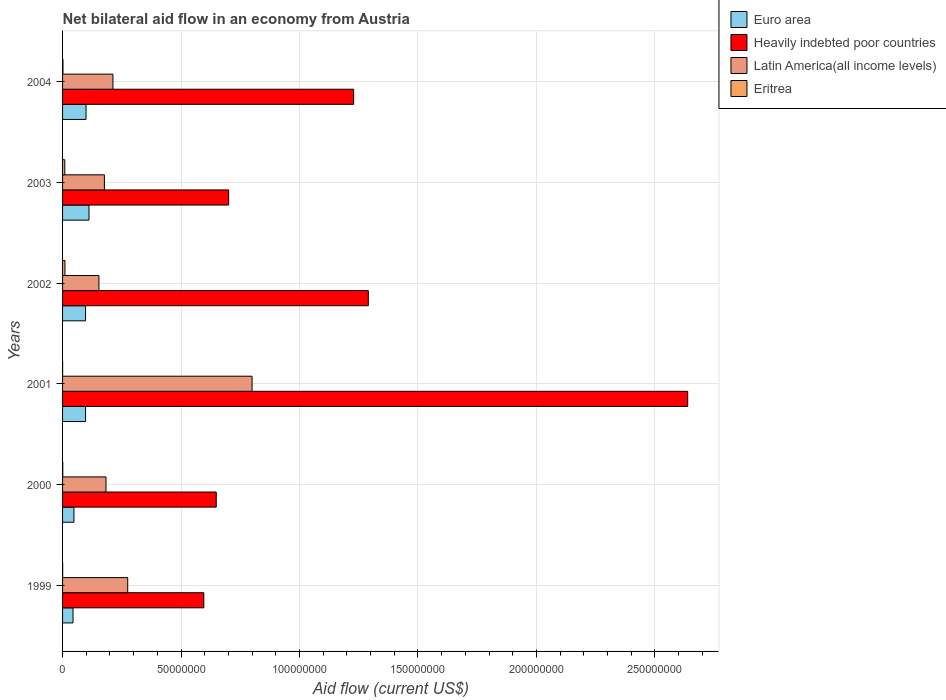How many groups of bars are there?
Ensure brevity in your answer.  6. What is the label of the 4th group of bars from the top?
Give a very brief answer. 2001. What is the net bilateral aid flow in Latin America(all income levels) in 2003?
Give a very brief answer. 1.77e+07. Across all years, what is the maximum net bilateral aid flow in Heavily indebted poor countries?
Make the answer very short. 2.64e+08. Across all years, what is the minimum net bilateral aid flow in Euro area?
Offer a very short reply. 4.42e+06. In which year was the net bilateral aid flow in Latin America(all income levels) maximum?
Your answer should be compact. 2001. What is the total net bilateral aid flow in Eritrea in the graph?
Make the answer very short. 2.27e+06. What is the difference between the net bilateral aid flow in Heavily indebted poor countries in 2003 and that in 2004?
Keep it short and to the point. -5.27e+07. What is the difference between the net bilateral aid flow in Latin America(all income levels) in 2003 and the net bilateral aid flow in Heavily indebted poor countries in 2002?
Keep it short and to the point. -1.11e+08. What is the average net bilateral aid flow in Latin America(all income levels) per year?
Provide a succinct answer. 3.00e+07. In the year 2002, what is the difference between the net bilateral aid flow in Latin America(all income levels) and net bilateral aid flow in Eritrea?
Keep it short and to the point. 1.43e+07. What is the ratio of the net bilateral aid flow in Heavily indebted poor countries in 2003 to that in 2004?
Make the answer very short. 0.57. Is the net bilateral aid flow in Eritrea in 2002 less than that in 2003?
Keep it short and to the point. No. What is the difference between the highest and the second highest net bilateral aid flow in Euro area?
Your answer should be very brief. 1.25e+06. What is the difference between the highest and the lowest net bilateral aid flow in Euro area?
Ensure brevity in your answer.  6.74e+06. In how many years, is the net bilateral aid flow in Euro area greater than the average net bilateral aid flow in Euro area taken over all years?
Offer a terse response. 4. Is the sum of the net bilateral aid flow in Euro area in 1999 and 2002 greater than the maximum net bilateral aid flow in Heavily indebted poor countries across all years?
Provide a short and direct response. No. What does the 3rd bar from the top in 2004 represents?
Provide a short and direct response. Heavily indebted poor countries. What does the 2nd bar from the bottom in 2000 represents?
Ensure brevity in your answer.  Heavily indebted poor countries. Are all the bars in the graph horizontal?
Offer a very short reply. Yes. Where does the legend appear in the graph?
Ensure brevity in your answer.  Top right. How are the legend labels stacked?
Offer a terse response. Vertical. What is the title of the graph?
Offer a very short reply. Net bilateral aid flow in an economy from Austria. Does "Thailand" appear as one of the legend labels in the graph?
Provide a short and direct response. No. What is the Aid flow (current US$) of Euro area in 1999?
Your answer should be compact. 4.42e+06. What is the Aid flow (current US$) of Heavily indebted poor countries in 1999?
Provide a short and direct response. 5.96e+07. What is the Aid flow (current US$) of Latin America(all income levels) in 1999?
Keep it short and to the point. 2.75e+07. What is the Aid flow (current US$) of Euro area in 2000?
Give a very brief answer. 4.80e+06. What is the Aid flow (current US$) in Heavily indebted poor countries in 2000?
Your answer should be very brief. 6.49e+07. What is the Aid flow (current US$) of Latin America(all income levels) in 2000?
Provide a short and direct response. 1.83e+07. What is the Aid flow (current US$) of Euro area in 2001?
Your answer should be very brief. 9.71e+06. What is the Aid flow (current US$) of Heavily indebted poor countries in 2001?
Make the answer very short. 2.64e+08. What is the Aid flow (current US$) in Latin America(all income levels) in 2001?
Offer a terse response. 8.00e+07. What is the Aid flow (current US$) of Euro area in 2002?
Keep it short and to the point. 9.71e+06. What is the Aid flow (current US$) in Heavily indebted poor countries in 2002?
Ensure brevity in your answer.  1.29e+08. What is the Aid flow (current US$) of Latin America(all income levels) in 2002?
Your answer should be compact. 1.54e+07. What is the Aid flow (current US$) of Eritrea in 2002?
Provide a short and direct response. 1.01e+06. What is the Aid flow (current US$) in Euro area in 2003?
Offer a very short reply. 1.12e+07. What is the Aid flow (current US$) of Heavily indebted poor countries in 2003?
Your answer should be very brief. 7.01e+07. What is the Aid flow (current US$) of Latin America(all income levels) in 2003?
Provide a succinct answer. 1.77e+07. What is the Aid flow (current US$) of Eritrea in 2003?
Your response must be concise. 9.40e+05. What is the Aid flow (current US$) of Euro area in 2004?
Your answer should be compact. 9.91e+06. What is the Aid flow (current US$) in Heavily indebted poor countries in 2004?
Offer a very short reply. 1.23e+08. What is the Aid flow (current US$) in Latin America(all income levels) in 2004?
Your response must be concise. 2.13e+07. Across all years, what is the maximum Aid flow (current US$) of Euro area?
Your answer should be very brief. 1.12e+07. Across all years, what is the maximum Aid flow (current US$) in Heavily indebted poor countries?
Provide a short and direct response. 2.64e+08. Across all years, what is the maximum Aid flow (current US$) of Latin America(all income levels)?
Keep it short and to the point. 8.00e+07. Across all years, what is the maximum Aid flow (current US$) in Eritrea?
Give a very brief answer. 1.01e+06. Across all years, what is the minimum Aid flow (current US$) in Euro area?
Your answer should be very brief. 4.42e+06. Across all years, what is the minimum Aid flow (current US$) of Heavily indebted poor countries?
Give a very brief answer. 5.96e+07. Across all years, what is the minimum Aid flow (current US$) in Latin America(all income levels)?
Ensure brevity in your answer.  1.54e+07. What is the total Aid flow (current US$) of Euro area in the graph?
Ensure brevity in your answer.  4.97e+07. What is the total Aid flow (current US$) in Heavily indebted poor countries in the graph?
Your answer should be compact. 7.10e+08. What is the total Aid flow (current US$) in Latin America(all income levels) in the graph?
Your answer should be very brief. 1.80e+08. What is the total Aid flow (current US$) in Eritrea in the graph?
Your answer should be very brief. 2.27e+06. What is the difference between the Aid flow (current US$) in Euro area in 1999 and that in 2000?
Offer a terse response. -3.80e+05. What is the difference between the Aid flow (current US$) in Heavily indebted poor countries in 1999 and that in 2000?
Make the answer very short. -5.24e+06. What is the difference between the Aid flow (current US$) of Latin America(all income levels) in 1999 and that in 2000?
Your response must be concise. 9.17e+06. What is the difference between the Aid flow (current US$) in Eritrea in 1999 and that in 2000?
Provide a succinct answer. -5.00e+04. What is the difference between the Aid flow (current US$) in Euro area in 1999 and that in 2001?
Keep it short and to the point. -5.29e+06. What is the difference between the Aid flow (current US$) of Heavily indebted poor countries in 1999 and that in 2001?
Ensure brevity in your answer.  -2.04e+08. What is the difference between the Aid flow (current US$) of Latin America(all income levels) in 1999 and that in 2001?
Provide a succinct answer. -5.25e+07. What is the difference between the Aid flow (current US$) of Eritrea in 1999 and that in 2001?
Give a very brief answer. 2.00e+04. What is the difference between the Aid flow (current US$) of Euro area in 1999 and that in 2002?
Give a very brief answer. -5.29e+06. What is the difference between the Aid flow (current US$) of Heavily indebted poor countries in 1999 and that in 2002?
Keep it short and to the point. -6.94e+07. What is the difference between the Aid flow (current US$) in Latin America(all income levels) in 1999 and that in 2002?
Make the answer very short. 1.22e+07. What is the difference between the Aid flow (current US$) in Eritrea in 1999 and that in 2002?
Give a very brief answer. -9.70e+05. What is the difference between the Aid flow (current US$) in Euro area in 1999 and that in 2003?
Provide a short and direct response. -6.74e+06. What is the difference between the Aid flow (current US$) of Heavily indebted poor countries in 1999 and that in 2003?
Ensure brevity in your answer.  -1.05e+07. What is the difference between the Aid flow (current US$) in Latin America(all income levels) in 1999 and that in 2003?
Give a very brief answer. 9.84e+06. What is the difference between the Aid flow (current US$) in Eritrea in 1999 and that in 2003?
Your answer should be compact. -9.00e+05. What is the difference between the Aid flow (current US$) of Euro area in 1999 and that in 2004?
Offer a very short reply. -5.49e+06. What is the difference between the Aid flow (current US$) of Heavily indebted poor countries in 1999 and that in 2004?
Make the answer very short. -6.32e+07. What is the difference between the Aid flow (current US$) in Latin America(all income levels) in 1999 and that in 2004?
Make the answer very short. 6.23e+06. What is the difference between the Aid flow (current US$) of Euro area in 2000 and that in 2001?
Your answer should be very brief. -4.91e+06. What is the difference between the Aid flow (current US$) in Heavily indebted poor countries in 2000 and that in 2001?
Your response must be concise. -1.99e+08. What is the difference between the Aid flow (current US$) in Latin America(all income levels) in 2000 and that in 2001?
Your answer should be compact. -6.17e+07. What is the difference between the Aid flow (current US$) in Euro area in 2000 and that in 2002?
Your response must be concise. -4.91e+06. What is the difference between the Aid flow (current US$) in Heavily indebted poor countries in 2000 and that in 2002?
Your answer should be compact. -6.42e+07. What is the difference between the Aid flow (current US$) of Latin America(all income levels) in 2000 and that in 2002?
Provide a succinct answer. 2.98e+06. What is the difference between the Aid flow (current US$) of Eritrea in 2000 and that in 2002?
Provide a short and direct response. -9.20e+05. What is the difference between the Aid flow (current US$) of Euro area in 2000 and that in 2003?
Your response must be concise. -6.36e+06. What is the difference between the Aid flow (current US$) in Heavily indebted poor countries in 2000 and that in 2003?
Provide a short and direct response. -5.24e+06. What is the difference between the Aid flow (current US$) in Latin America(all income levels) in 2000 and that in 2003?
Keep it short and to the point. 6.70e+05. What is the difference between the Aid flow (current US$) of Eritrea in 2000 and that in 2003?
Offer a very short reply. -8.50e+05. What is the difference between the Aid flow (current US$) of Euro area in 2000 and that in 2004?
Provide a succinct answer. -5.11e+06. What is the difference between the Aid flow (current US$) of Heavily indebted poor countries in 2000 and that in 2004?
Your answer should be compact. -5.80e+07. What is the difference between the Aid flow (current US$) of Latin America(all income levels) in 2000 and that in 2004?
Keep it short and to the point. -2.94e+06. What is the difference between the Aid flow (current US$) of Eritrea in 2000 and that in 2004?
Offer a terse response. -8.00e+04. What is the difference between the Aid flow (current US$) of Euro area in 2001 and that in 2002?
Ensure brevity in your answer.  0. What is the difference between the Aid flow (current US$) in Heavily indebted poor countries in 2001 and that in 2002?
Your answer should be very brief. 1.35e+08. What is the difference between the Aid flow (current US$) of Latin America(all income levels) in 2001 and that in 2002?
Provide a short and direct response. 6.46e+07. What is the difference between the Aid flow (current US$) in Eritrea in 2001 and that in 2002?
Provide a short and direct response. -9.90e+05. What is the difference between the Aid flow (current US$) in Euro area in 2001 and that in 2003?
Ensure brevity in your answer.  -1.45e+06. What is the difference between the Aid flow (current US$) in Heavily indebted poor countries in 2001 and that in 2003?
Your answer should be compact. 1.94e+08. What is the difference between the Aid flow (current US$) in Latin America(all income levels) in 2001 and that in 2003?
Ensure brevity in your answer.  6.23e+07. What is the difference between the Aid flow (current US$) of Eritrea in 2001 and that in 2003?
Provide a succinct answer. -9.20e+05. What is the difference between the Aid flow (current US$) of Heavily indebted poor countries in 2001 and that in 2004?
Provide a short and direct response. 1.41e+08. What is the difference between the Aid flow (current US$) of Latin America(all income levels) in 2001 and that in 2004?
Your answer should be very brief. 5.87e+07. What is the difference between the Aid flow (current US$) in Eritrea in 2001 and that in 2004?
Your answer should be very brief. -1.50e+05. What is the difference between the Aid flow (current US$) of Euro area in 2002 and that in 2003?
Make the answer very short. -1.45e+06. What is the difference between the Aid flow (current US$) of Heavily indebted poor countries in 2002 and that in 2003?
Your response must be concise. 5.90e+07. What is the difference between the Aid flow (current US$) in Latin America(all income levels) in 2002 and that in 2003?
Make the answer very short. -2.31e+06. What is the difference between the Aid flow (current US$) of Eritrea in 2002 and that in 2003?
Provide a succinct answer. 7.00e+04. What is the difference between the Aid flow (current US$) of Heavily indebted poor countries in 2002 and that in 2004?
Your answer should be compact. 6.21e+06. What is the difference between the Aid flow (current US$) of Latin America(all income levels) in 2002 and that in 2004?
Ensure brevity in your answer.  -5.92e+06. What is the difference between the Aid flow (current US$) of Eritrea in 2002 and that in 2004?
Give a very brief answer. 8.40e+05. What is the difference between the Aid flow (current US$) in Euro area in 2003 and that in 2004?
Provide a succinct answer. 1.25e+06. What is the difference between the Aid flow (current US$) of Heavily indebted poor countries in 2003 and that in 2004?
Ensure brevity in your answer.  -5.27e+07. What is the difference between the Aid flow (current US$) of Latin America(all income levels) in 2003 and that in 2004?
Your answer should be very brief. -3.61e+06. What is the difference between the Aid flow (current US$) of Eritrea in 2003 and that in 2004?
Provide a short and direct response. 7.70e+05. What is the difference between the Aid flow (current US$) in Euro area in 1999 and the Aid flow (current US$) in Heavily indebted poor countries in 2000?
Your response must be concise. -6.04e+07. What is the difference between the Aid flow (current US$) in Euro area in 1999 and the Aid flow (current US$) in Latin America(all income levels) in 2000?
Provide a short and direct response. -1.39e+07. What is the difference between the Aid flow (current US$) of Euro area in 1999 and the Aid flow (current US$) of Eritrea in 2000?
Offer a terse response. 4.33e+06. What is the difference between the Aid flow (current US$) of Heavily indebted poor countries in 1999 and the Aid flow (current US$) of Latin America(all income levels) in 2000?
Ensure brevity in your answer.  4.13e+07. What is the difference between the Aid flow (current US$) of Heavily indebted poor countries in 1999 and the Aid flow (current US$) of Eritrea in 2000?
Provide a succinct answer. 5.95e+07. What is the difference between the Aid flow (current US$) of Latin America(all income levels) in 1999 and the Aid flow (current US$) of Eritrea in 2000?
Your response must be concise. 2.74e+07. What is the difference between the Aid flow (current US$) of Euro area in 1999 and the Aid flow (current US$) of Heavily indebted poor countries in 2001?
Provide a short and direct response. -2.59e+08. What is the difference between the Aid flow (current US$) of Euro area in 1999 and the Aid flow (current US$) of Latin America(all income levels) in 2001?
Offer a terse response. -7.56e+07. What is the difference between the Aid flow (current US$) in Euro area in 1999 and the Aid flow (current US$) in Eritrea in 2001?
Provide a short and direct response. 4.40e+06. What is the difference between the Aid flow (current US$) in Heavily indebted poor countries in 1999 and the Aid flow (current US$) in Latin America(all income levels) in 2001?
Make the answer very short. -2.04e+07. What is the difference between the Aid flow (current US$) of Heavily indebted poor countries in 1999 and the Aid flow (current US$) of Eritrea in 2001?
Your response must be concise. 5.96e+07. What is the difference between the Aid flow (current US$) of Latin America(all income levels) in 1999 and the Aid flow (current US$) of Eritrea in 2001?
Your answer should be very brief. 2.75e+07. What is the difference between the Aid flow (current US$) of Euro area in 1999 and the Aid flow (current US$) of Heavily indebted poor countries in 2002?
Your answer should be compact. -1.25e+08. What is the difference between the Aid flow (current US$) in Euro area in 1999 and the Aid flow (current US$) in Latin America(all income levels) in 2002?
Your answer should be very brief. -1.09e+07. What is the difference between the Aid flow (current US$) of Euro area in 1999 and the Aid flow (current US$) of Eritrea in 2002?
Ensure brevity in your answer.  3.41e+06. What is the difference between the Aid flow (current US$) of Heavily indebted poor countries in 1999 and the Aid flow (current US$) of Latin America(all income levels) in 2002?
Provide a short and direct response. 4.43e+07. What is the difference between the Aid flow (current US$) of Heavily indebted poor countries in 1999 and the Aid flow (current US$) of Eritrea in 2002?
Offer a terse response. 5.86e+07. What is the difference between the Aid flow (current US$) of Latin America(all income levels) in 1999 and the Aid flow (current US$) of Eritrea in 2002?
Keep it short and to the point. 2.65e+07. What is the difference between the Aid flow (current US$) in Euro area in 1999 and the Aid flow (current US$) in Heavily indebted poor countries in 2003?
Provide a short and direct response. -6.57e+07. What is the difference between the Aid flow (current US$) of Euro area in 1999 and the Aid flow (current US$) of Latin America(all income levels) in 2003?
Your response must be concise. -1.32e+07. What is the difference between the Aid flow (current US$) of Euro area in 1999 and the Aid flow (current US$) of Eritrea in 2003?
Offer a terse response. 3.48e+06. What is the difference between the Aid flow (current US$) of Heavily indebted poor countries in 1999 and the Aid flow (current US$) of Latin America(all income levels) in 2003?
Your answer should be compact. 4.20e+07. What is the difference between the Aid flow (current US$) in Heavily indebted poor countries in 1999 and the Aid flow (current US$) in Eritrea in 2003?
Make the answer very short. 5.87e+07. What is the difference between the Aid flow (current US$) in Latin America(all income levels) in 1999 and the Aid flow (current US$) in Eritrea in 2003?
Make the answer very short. 2.66e+07. What is the difference between the Aid flow (current US$) of Euro area in 1999 and the Aid flow (current US$) of Heavily indebted poor countries in 2004?
Keep it short and to the point. -1.18e+08. What is the difference between the Aid flow (current US$) of Euro area in 1999 and the Aid flow (current US$) of Latin America(all income levels) in 2004?
Your answer should be compact. -1.68e+07. What is the difference between the Aid flow (current US$) of Euro area in 1999 and the Aid flow (current US$) of Eritrea in 2004?
Your answer should be compact. 4.25e+06. What is the difference between the Aid flow (current US$) of Heavily indebted poor countries in 1999 and the Aid flow (current US$) of Latin America(all income levels) in 2004?
Provide a short and direct response. 3.84e+07. What is the difference between the Aid flow (current US$) in Heavily indebted poor countries in 1999 and the Aid flow (current US$) in Eritrea in 2004?
Offer a very short reply. 5.95e+07. What is the difference between the Aid flow (current US$) of Latin America(all income levels) in 1999 and the Aid flow (current US$) of Eritrea in 2004?
Keep it short and to the point. 2.73e+07. What is the difference between the Aid flow (current US$) in Euro area in 2000 and the Aid flow (current US$) in Heavily indebted poor countries in 2001?
Your response must be concise. -2.59e+08. What is the difference between the Aid flow (current US$) of Euro area in 2000 and the Aid flow (current US$) of Latin America(all income levels) in 2001?
Give a very brief answer. -7.52e+07. What is the difference between the Aid flow (current US$) in Euro area in 2000 and the Aid flow (current US$) in Eritrea in 2001?
Ensure brevity in your answer.  4.78e+06. What is the difference between the Aid flow (current US$) in Heavily indebted poor countries in 2000 and the Aid flow (current US$) in Latin America(all income levels) in 2001?
Give a very brief answer. -1.51e+07. What is the difference between the Aid flow (current US$) of Heavily indebted poor countries in 2000 and the Aid flow (current US$) of Eritrea in 2001?
Offer a very short reply. 6.48e+07. What is the difference between the Aid flow (current US$) of Latin America(all income levels) in 2000 and the Aid flow (current US$) of Eritrea in 2001?
Your response must be concise. 1.83e+07. What is the difference between the Aid flow (current US$) of Euro area in 2000 and the Aid flow (current US$) of Heavily indebted poor countries in 2002?
Your answer should be compact. -1.24e+08. What is the difference between the Aid flow (current US$) of Euro area in 2000 and the Aid flow (current US$) of Latin America(all income levels) in 2002?
Your response must be concise. -1.06e+07. What is the difference between the Aid flow (current US$) of Euro area in 2000 and the Aid flow (current US$) of Eritrea in 2002?
Offer a very short reply. 3.79e+06. What is the difference between the Aid flow (current US$) of Heavily indebted poor countries in 2000 and the Aid flow (current US$) of Latin America(all income levels) in 2002?
Provide a short and direct response. 4.95e+07. What is the difference between the Aid flow (current US$) of Heavily indebted poor countries in 2000 and the Aid flow (current US$) of Eritrea in 2002?
Ensure brevity in your answer.  6.39e+07. What is the difference between the Aid flow (current US$) in Latin America(all income levels) in 2000 and the Aid flow (current US$) in Eritrea in 2002?
Your answer should be very brief. 1.73e+07. What is the difference between the Aid flow (current US$) in Euro area in 2000 and the Aid flow (current US$) in Heavily indebted poor countries in 2003?
Offer a terse response. -6.53e+07. What is the difference between the Aid flow (current US$) of Euro area in 2000 and the Aid flow (current US$) of Latin America(all income levels) in 2003?
Make the answer very short. -1.29e+07. What is the difference between the Aid flow (current US$) of Euro area in 2000 and the Aid flow (current US$) of Eritrea in 2003?
Offer a terse response. 3.86e+06. What is the difference between the Aid flow (current US$) of Heavily indebted poor countries in 2000 and the Aid flow (current US$) of Latin America(all income levels) in 2003?
Provide a succinct answer. 4.72e+07. What is the difference between the Aid flow (current US$) of Heavily indebted poor countries in 2000 and the Aid flow (current US$) of Eritrea in 2003?
Keep it short and to the point. 6.39e+07. What is the difference between the Aid flow (current US$) in Latin America(all income levels) in 2000 and the Aid flow (current US$) in Eritrea in 2003?
Provide a succinct answer. 1.74e+07. What is the difference between the Aid flow (current US$) of Euro area in 2000 and the Aid flow (current US$) of Heavily indebted poor countries in 2004?
Your answer should be compact. -1.18e+08. What is the difference between the Aid flow (current US$) of Euro area in 2000 and the Aid flow (current US$) of Latin America(all income levels) in 2004?
Ensure brevity in your answer.  -1.65e+07. What is the difference between the Aid flow (current US$) of Euro area in 2000 and the Aid flow (current US$) of Eritrea in 2004?
Keep it short and to the point. 4.63e+06. What is the difference between the Aid flow (current US$) of Heavily indebted poor countries in 2000 and the Aid flow (current US$) of Latin America(all income levels) in 2004?
Offer a terse response. 4.36e+07. What is the difference between the Aid flow (current US$) in Heavily indebted poor countries in 2000 and the Aid flow (current US$) in Eritrea in 2004?
Keep it short and to the point. 6.47e+07. What is the difference between the Aid flow (current US$) in Latin America(all income levels) in 2000 and the Aid flow (current US$) in Eritrea in 2004?
Your answer should be compact. 1.82e+07. What is the difference between the Aid flow (current US$) in Euro area in 2001 and the Aid flow (current US$) in Heavily indebted poor countries in 2002?
Provide a succinct answer. -1.19e+08. What is the difference between the Aid flow (current US$) in Euro area in 2001 and the Aid flow (current US$) in Latin America(all income levels) in 2002?
Your answer should be compact. -5.64e+06. What is the difference between the Aid flow (current US$) of Euro area in 2001 and the Aid flow (current US$) of Eritrea in 2002?
Ensure brevity in your answer.  8.70e+06. What is the difference between the Aid flow (current US$) of Heavily indebted poor countries in 2001 and the Aid flow (current US$) of Latin America(all income levels) in 2002?
Your answer should be very brief. 2.49e+08. What is the difference between the Aid flow (current US$) of Heavily indebted poor countries in 2001 and the Aid flow (current US$) of Eritrea in 2002?
Provide a succinct answer. 2.63e+08. What is the difference between the Aid flow (current US$) in Latin America(all income levels) in 2001 and the Aid flow (current US$) in Eritrea in 2002?
Your answer should be compact. 7.90e+07. What is the difference between the Aid flow (current US$) in Euro area in 2001 and the Aid flow (current US$) in Heavily indebted poor countries in 2003?
Keep it short and to the point. -6.04e+07. What is the difference between the Aid flow (current US$) in Euro area in 2001 and the Aid flow (current US$) in Latin America(all income levels) in 2003?
Give a very brief answer. -7.95e+06. What is the difference between the Aid flow (current US$) in Euro area in 2001 and the Aid flow (current US$) in Eritrea in 2003?
Your answer should be very brief. 8.77e+06. What is the difference between the Aid flow (current US$) of Heavily indebted poor countries in 2001 and the Aid flow (current US$) of Latin America(all income levels) in 2003?
Provide a succinct answer. 2.46e+08. What is the difference between the Aid flow (current US$) of Heavily indebted poor countries in 2001 and the Aid flow (current US$) of Eritrea in 2003?
Ensure brevity in your answer.  2.63e+08. What is the difference between the Aid flow (current US$) in Latin America(all income levels) in 2001 and the Aid flow (current US$) in Eritrea in 2003?
Provide a succinct answer. 7.90e+07. What is the difference between the Aid flow (current US$) of Euro area in 2001 and the Aid flow (current US$) of Heavily indebted poor countries in 2004?
Keep it short and to the point. -1.13e+08. What is the difference between the Aid flow (current US$) of Euro area in 2001 and the Aid flow (current US$) of Latin America(all income levels) in 2004?
Your response must be concise. -1.16e+07. What is the difference between the Aid flow (current US$) in Euro area in 2001 and the Aid flow (current US$) in Eritrea in 2004?
Ensure brevity in your answer.  9.54e+06. What is the difference between the Aid flow (current US$) of Heavily indebted poor countries in 2001 and the Aid flow (current US$) of Latin America(all income levels) in 2004?
Give a very brief answer. 2.43e+08. What is the difference between the Aid flow (current US$) of Heavily indebted poor countries in 2001 and the Aid flow (current US$) of Eritrea in 2004?
Ensure brevity in your answer.  2.64e+08. What is the difference between the Aid flow (current US$) of Latin America(all income levels) in 2001 and the Aid flow (current US$) of Eritrea in 2004?
Ensure brevity in your answer.  7.98e+07. What is the difference between the Aid flow (current US$) in Euro area in 2002 and the Aid flow (current US$) in Heavily indebted poor countries in 2003?
Provide a short and direct response. -6.04e+07. What is the difference between the Aid flow (current US$) in Euro area in 2002 and the Aid flow (current US$) in Latin America(all income levels) in 2003?
Your answer should be compact. -7.95e+06. What is the difference between the Aid flow (current US$) of Euro area in 2002 and the Aid flow (current US$) of Eritrea in 2003?
Provide a succinct answer. 8.77e+06. What is the difference between the Aid flow (current US$) in Heavily indebted poor countries in 2002 and the Aid flow (current US$) in Latin America(all income levels) in 2003?
Provide a short and direct response. 1.11e+08. What is the difference between the Aid flow (current US$) in Heavily indebted poor countries in 2002 and the Aid flow (current US$) in Eritrea in 2003?
Provide a short and direct response. 1.28e+08. What is the difference between the Aid flow (current US$) in Latin America(all income levels) in 2002 and the Aid flow (current US$) in Eritrea in 2003?
Your answer should be compact. 1.44e+07. What is the difference between the Aid flow (current US$) in Euro area in 2002 and the Aid flow (current US$) in Heavily indebted poor countries in 2004?
Make the answer very short. -1.13e+08. What is the difference between the Aid flow (current US$) of Euro area in 2002 and the Aid flow (current US$) of Latin America(all income levels) in 2004?
Make the answer very short. -1.16e+07. What is the difference between the Aid flow (current US$) in Euro area in 2002 and the Aid flow (current US$) in Eritrea in 2004?
Give a very brief answer. 9.54e+06. What is the difference between the Aid flow (current US$) in Heavily indebted poor countries in 2002 and the Aid flow (current US$) in Latin America(all income levels) in 2004?
Provide a short and direct response. 1.08e+08. What is the difference between the Aid flow (current US$) in Heavily indebted poor countries in 2002 and the Aid flow (current US$) in Eritrea in 2004?
Ensure brevity in your answer.  1.29e+08. What is the difference between the Aid flow (current US$) of Latin America(all income levels) in 2002 and the Aid flow (current US$) of Eritrea in 2004?
Provide a short and direct response. 1.52e+07. What is the difference between the Aid flow (current US$) in Euro area in 2003 and the Aid flow (current US$) in Heavily indebted poor countries in 2004?
Provide a succinct answer. -1.12e+08. What is the difference between the Aid flow (current US$) in Euro area in 2003 and the Aid flow (current US$) in Latin America(all income levels) in 2004?
Your answer should be compact. -1.01e+07. What is the difference between the Aid flow (current US$) in Euro area in 2003 and the Aid flow (current US$) in Eritrea in 2004?
Offer a very short reply. 1.10e+07. What is the difference between the Aid flow (current US$) of Heavily indebted poor countries in 2003 and the Aid flow (current US$) of Latin America(all income levels) in 2004?
Offer a very short reply. 4.88e+07. What is the difference between the Aid flow (current US$) of Heavily indebted poor countries in 2003 and the Aid flow (current US$) of Eritrea in 2004?
Your answer should be very brief. 6.99e+07. What is the difference between the Aid flow (current US$) in Latin America(all income levels) in 2003 and the Aid flow (current US$) in Eritrea in 2004?
Ensure brevity in your answer.  1.75e+07. What is the average Aid flow (current US$) of Euro area per year?
Offer a very short reply. 8.28e+06. What is the average Aid flow (current US$) of Heavily indebted poor countries per year?
Provide a short and direct response. 1.18e+08. What is the average Aid flow (current US$) in Latin America(all income levels) per year?
Give a very brief answer. 3.00e+07. What is the average Aid flow (current US$) in Eritrea per year?
Your response must be concise. 3.78e+05. In the year 1999, what is the difference between the Aid flow (current US$) of Euro area and Aid flow (current US$) of Heavily indebted poor countries?
Provide a succinct answer. -5.52e+07. In the year 1999, what is the difference between the Aid flow (current US$) in Euro area and Aid flow (current US$) in Latin America(all income levels)?
Provide a short and direct response. -2.31e+07. In the year 1999, what is the difference between the Aid flow (current US$) in Euro area and Aid flow (current US$) in Eritrea?
Offer a very short reply. 4.38e+06. In the year 1999, what is the difference between the Aid flow (current US$) in Heavily indebted poor countries and Aid flow (current US$) in Latin America(all income levels)?
Make the answer very short. 3.21e+07. In the year 1999, what is the difference between the Aid flow (current US$) of Heavily indebted poor countries and Aid flow (current US$) of Eritrea?
Offer a very short reply. 5.96e+07. In the year 1999, what is the difference between the Aid flow (current US$) of Latin America(all income levels) and Aid flow (current US$) of Eritrea?
Keep it short and to the point. 2.75e+07. In the year 2000, what is the difference between the Aid flow (current US$) in Euro area and Aid flow (current US$) in Heavily indebted poor countries?
Your answer should be compact. -6.01e+07. In the year 2000, what is the difference between the Aid flow (current US$) of Euro area and Aid flow (current US$) of Latin America(all income levels)?
Your answer should be very brief. -1.35e+07. In the year 2000, what is the difference between the Aid flow (current US$) of Euro area and Aid flow (current US$) of Eritrea?
Your response must be concise. 4.71e+06. In the year 2000, what is the difference between the Aid flow (current US$) of Heavily indebted poor countries and Aid flow (current US$) of Latin America(all income levels)?
Give a very brief answer. 4.65e+07. In the year 2000, what is the difference between the Aid flow (current US$) of Heavily indebted poor countries and Aid flow (current US$) of Eritrea?
Give a very brief answer. 6.48e+07. In the year 2000, what is the difference between the Aid flow (current US$) in Latin America(all income levels) and Aid flow (current US$) in Eritrea?
Your response must be concise. 1.82e+07. In the year 2001, what is the difference between the Aid flow (current US$) in Euro area and Aid flow (current US$) in Heavily indebted poor countries?
Keep it short and to the point. -2.54e+08. In the year 2001, what is the difference between the Aid flow (current US$) in Euro area and Aid flow (current US$) in Latin America(all income levels)?
Provide a short and direct response. -7.03e+07. In the year 2001, what is the difference between the Aid flow (current US$) in Euro area and Aid flow (current US$) in Eritrea?
Offer a terse response. 9.69e+06. In the year 2001, what is the difference between the Aid flow (current US$) in Heavily indebted poor countries and Aid flow (current US$) in Latin America(all income levels)?
Ensure brevity in your answer.  1.84e+08. In the year 2001, what is the difference between the Aid flow (current US$) in Heavily indebted poor countries and Aid flow (current US$) in Eritrea?
Offer a terse response. 2.64e+08. In the year 2001, what is the difference between the Aid flow (current US$) of Latin America(all income levels) and Aid flow (current US$) of Eritrea?
Ensure brevity in your answer.  8.00e+07. In the year 2002, what is the difference between the Aid flow (current US$) in Euro area and Aid flow (current US$) in Heavily indebted poor countries?
Make the answer very short. -1.19e+08. In the year 2002, what is the difference between the Aid flow (current US$) in Euro area and Aid flow (current US$) in Latin America(all income levels)?
Give a very brief answer. -5.64e+06. In the year 2002, what is the difference between the Aid flow (current US$) of Euro area and Aid flow (current US$) of Eritrea?
Your answer should be very brief. 8.70e+06. In the year 2002, what is the difference between the Aid flow (current US$) of Heavily indebted poor countries and Aid flow (current US$) of Latin America(all income levels)?
Your response must be concise. 1.14e+08. In the year 2002, what is the difference between the Aid flow (current US$) in Heavily indebted poor countries and Aid flow (current US$) in Eritrea?
Your answer should be compact. 1.28e+08. In the year 2002, what is the difference between the Aid flow (current US$) in Latin America(all income levels) and Aid flow (current US$) in Eritrea?
Provide a succinct answer. 1.43e+07. In the year 2003, what is the difference between the Aid flow (current US$) in Euro area and Aid flow (current US$) in Heavily indebted poor countries?
Provide a short and direct response. -5.90e+07. In the year 2003, what is the difference between the Aid flow (current US$) of Euro area and Aid flow (current US$) of Latin America(all income levels)?
Make the answer very short. -6.50e+06. In the year 2003, what is the difference between the Aid flow (current US$) in Euro area and Aid flow (current US$) in Eritrea?
Ensure brevity in your answer.  1.02e+07. In the year 2003, what is the difference between the Aid flow (current US$) of Heavily indebted poor countries and Aid flow (current US$) of Latin America(all income levels)?
Provide a succinct answer. 5.24e+07. In the year 2003, what is the difference between the Aid flow (current US$) in Heavily indebted poor countries and Aid flow (current US$) in Eritrea?
Make the answer very short. 6.92e+07. In the year 2003, what is the difference between the Aid flow (current US$) in Latin America(all income levels) and Aid flow (current US$) in Eritrea?
Give a very brief answer. 1.67e+07. In the year 2004, what is the difference between the Aid flow (current US$) in Euro area and Aid flow (current US$) in Heavily indebted poor countries?
Keep it short and to the point. -1.13e+08. In the year 2004, what is the difference between the Aid flow (current US$) of Euro area and Aid flow (current US$) of Latin America(all income levels)?
Provide a succinct answer. -1.14e+07. In the year 2004, what is the difference between the Aid flow (current US$) in Euro area and Aid flow (current US$) in Eritrea?
Provide a short and direct response. 9.74e+06. In the year 2004, what is the difference between the Aid flow (current US$) in Heavily indebted poor countries and Aid flow (current US$) in Latin America(all income levels)?
Your answer should be very brief. 1.02e+08. In the year 2004, what is the difference between the Aid flow (current US$) in Heavily indebted poor countries and Aid flow (current US$) in Eritrea?
Offer a very short reply. 1.23e+08. In the year 2004, what is the difference between the Aid flow (current US$) in Latin America(all income levels) and Aid flow (current US$) in Eritrea?
Keep it short and to the point. 2.11e+07. What is the ratio of the Aid flow (current US$) in Euro area in 1999 to that in 2000?
Your answer should be compact. 0.92. What is the ratio of the Aid flow (current US$) of Heavily indebted poor countries in 1999 to that in 2000?
Offer a terse response. 0.92. What is the ratio of the Aid flow (current US$) in Latin America(all income levels) in 1999 to that in 2000?
Provide a short and direct response. 1.5. What is the ratio of the Aid flow (current US$) of Eritrea in 1999 to that in 2000?
Give a very brief answer. 0.44. What is the ratio of the Aid flow (current US$) of Euro area in 1999 to that in 2001?
Your answer should be compact. 0.46. What is the ratio of the Aid flow (current US$) in Heavily indebted poor countries in 1999 to that in 2001?
Give a very brief answer. 0.23. What is the ratio of the Aid flow (current US$) in Latin America(all income levels) in 1999 to that in 2001?
Offer a terse response. 0.34. What is the ratio of the Aid flow (current US$) of Eritrea in 1999 to that in 2001?
Ensure brevity in your answer.  2. What is the ratio of the Aid flow (current US$) of Euro area in 1999 to that in 2002?
Your response must be concise. 0.46. What is the ratio of the Aid flow (current US$) in Heavily indebted poor countries in 1999 to that in 2002?
Keep it short and to the point. 0.46. What is the ratio of the Aid flow (current US$) of Latin America(all income levels) in 1999 to that in 2002?
Keep it short and to the point. 1.79. What is the ratio of the Aid flow (current US$) of Eritrea in 1999 to that in 2002?
Your answer should be compact. 0.04. What is the ratio of the Aid flow (current US$) of Euro area in 1999 to that in 2003?
Provide a short and direct response. 0.4. What is the ratio of the Aid flow (current US$) in Heavily indebted poor countries in 1999 to that in 2003?
Your answer should be compact. 0.85. What is the ratio of the Aid flow (current US$) of Latin America(all income levels) in 1999 to that in 2003?
Your response must be concise. 1.56. What is the ratio of the Aid flow (current US$) in Eritrea in 1999 to that in 2003?
Give a very brief answer. 0.04. What is the ratio of the Aid flow (current US$) of Euro area in 1999 to that in 2004?
Your answer should be very brief. 0.45. What is the ratio of the Aid flow (current US$) in Heavily indebted poor countries in 1999 to that in 2004?
Your answer should be compact. 0.49. What is the ratio of the Aid flow (current US$) of Latin America(all income levels) in 1999 to that in 2004?
Keep it short and to the point. 1.29. What is the ratio of the Aid flow (current US$) in Eritrea in 1999 to that in 2004?
Your response must be concise. 0.24. What is the ratio of the Aid flow (current US$) in Euro area in 2000 to that in 2001?
Give a very brief answer. 0.49. What is the ratio of the Aid flow (current US$) in Heavily indebted poor countries in 2000 to that in 2001?
Give a very brief answer. 0.25. What is the ratio of the Aid flow (current US$) in Latin America(all income levels) in 2000 to that in 2001?
Your answer should be compact. 0.23. What is the ratio of the Aid flow (current US$) of Eritrea in 2000 to that in 2001?
Offer a very short reply. 4.5. What is the ratio of the Aid flow (current US$) in Euro area in 2000 to that in 2002?
Make the answer very short. 0.49. What is the ratio of the Aid flow (current US$) in Heavily indebted poor countries in 2000 to that in 2002?
Your answer should be very brief. 0.5. What is the ratio of the Aid flow (current US$) of Latin America(all income levels) in 2000 to that in 2002?
Your answer should be very brief. 1.19. What is the ratio of the Aid flow (current US$) in Eritrea in 2000 to that in 2002?
Offer a terse response. 0.09. What is the ratio of the Aid flow (current US$) of Euro area in 2000 to that in 2003?
Offer a terse response. 0.43. What is the ratio of the Aid flow (current US$) in Heavily indebted poor countries in 2000 to that in 2003?
Provide a short and direct response. 0.93. What is the ratio of the Aid flow (current US$) in Latin America(all income levels) in 2000 to that in 2003?
Give a very brief answer. 1.04. What is the ratio of the Aid flow (current US$) of Eritrea in 2000 to that in 2003?
Your response must be concise. 0.1. What is the ratio of the Aid flow (current US$) in Euro area in 2000 to that in 2004?
Give a very brief answer. 0.48. What is the ratio of the Aid flow (current US$) in Heavily indebted poor countries in 2000 to that in 2004?
Provide a short and direct response. 0.53. What is the ratio of the Aid flow (current US$) in Latin America(all income levels) in 2000 to that in 2004?
Your answer should be compact. 0.86. What is the ratio of the Aid flow (current US$) in Eritrea in 2000 to that in 2004?
Provide a succinct answer. 0.53. What is the ratio of the Aid flow (current US$) of Euro area in 2001 to that in 2002?
Provide a succinct answer. 1. What is the ratio of the Aid flow (current US$) of Heavily indebted poor countries in 2001 to that in 2002?
Provide a short and direct response. 2.04. What is the ratio of the Aid flow (current US$) in Latin America(all income levels) in 2001 to that in 2002?
Make the answer very short. 5.21. What is the ratio of the Aid flow (current US$) in Eritrea in 2001 to that in 2002?
Ensure brevity in your answer.  0.02. What is the ratio of the Aid flow (current US$) of Euro area in 2001 to that in 2003?
Make the answer very short. 0.87. What is the ratio of the Aid flow (current US$) of Heavily indebted poor countries in 2001 to that in 2003?
Keep it short and to the point. 3.76. What is the ratio of the Aid flow (current US$) in Latin America(all income levels) in 2001 to that in 2003?
Your response must be concise. 4.53. What is the ratio of the Aid flow (current US$) of Eritrea in 2001 to that in 2003?
Provide a short and direct response. 0.02. What is the ratio of the Aid flow (current US$) in Euro area in 2001 to that in 2004?
Your answer should be compact. 0.98. What is the ratio of the Aid flow (current US$) of Heavily indebted poor countries in 2001 to that in 2004?
Your response must be concise. 2.15. What is the ratio of the Aid flow (current US$) in Latin America(all income levels) in 2001 to that in 2004?
Ensure brevity in your answer.  3.76. What is the ratio of the Aid flow (current US$) of Eritrea in 2001 to that in 2004?
Your answer should be compact. 0.12. What is the ratio of the Aid flow (current US$) of Euro area in 2002 to that in 2003?
Offer a very short reply. 0.87. What is the ratio of the Aid flow (current US$) of Heavily indebted poor countries in 2002 to that in 2003?
Ensure brevity in your answer.  1.84. What is the ratio of the Aid flow (current US$) of Latin America(all income levels) in 2002 to that in 2003?
Offer a very short reply. 0.87. What is the ratio of the Aid flow (current US$) in Eritrea in 2002 to that in 2003?
Keep it short and to the point. 1.07. What is the ratio of the Aid flow (current US$) of Euro area in 2002 to that in 2004?
Ensure brevity in your answer.  0.98. What is the ratio of the Aid flow (current US$) in Heavily indebted poor countries in 2002 to that in 2004?
Make the answer very short. 1.05. What is the ratio of the Aid flow (current US$) in Latin America(all income levels) in 2002 to that in 2004?
Ensure brevity in your answer.  0.72. What is the ratio of the Aid flow (current US$) in Eritrea in 2002 to that in 2004?
Keep it short and to the point. 5.94. What is the ratio of the Aid flow (current US$) in Euro area in 2003 to that in 2004?
Keep it short and to the point. 1.13. What is the ratio of the Aid flow (current US$) in Heavily indebted poor countries in 2003 to that in 2004?
Ensure brevity in your answer.  0.57. What is the ratio of the Aid flow (current US$) of Latin America(all income levels) in 2003 to that in 2004?
Give a very brief answer. 0.83. What is the ratio of the Aid flow (current US$) in Eritrea in 2003 to that in 2004?
Make the answer very short. 5.53. What is the difference between the highest and the second highest Aid flow (current US$) of Euro area?
Provide a short and direct response. 1.25e+06. What is the difference between the highest and the second highest Aid flow (current US$) in Heavily indebted poor countries?
Make the answer very short. 1.35e+08. What is the difference between the highest and the second highest Aid flow (current US$) in Latin America(all income levels)?
Offer a very short reply. 5.25e+07. What is the difference between the highest and the second highest Aid flow (current US$) in Eritrea?
Your answer should be very brief. 7.00e+04. What is the difference between the highest and the lowest Aid flow (current US$) of Euro area?
Ensure brevity in your answer.  6.74e+06. What is the difference between the highest and the lowest Aid flow (current US$) of Heavily indebted poor countries?
Offer a very short reply. 2.04e+08. What is the difference between the highest and the lowest Aid flow (current US$) in Latin America(all income levels)?
Your answer should be compact. 6.46e+07. What is the difference between the highest and the lowest Aid flow (current US$) of Eritrea?
Make the answer very short. 9.90e+05. 